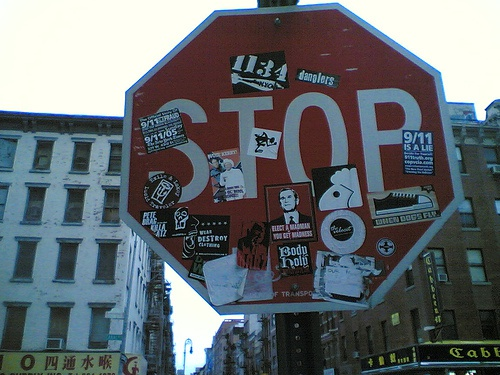Describe the objects in this image and their specific colors. I can see a stop sign in white, maroon, black, and gray tones in this image. 